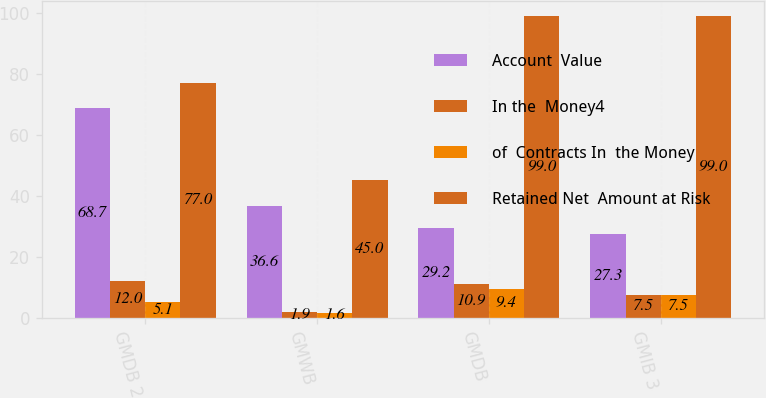<chart> <loc_0><loc_0><loc_500><loc_500><stacked_bar_chart><ecel><fcel>GMDB 2<fcel>GMWB<fcel>GMDB<fcel>GMIB 3<nl><fcel>Account  Value<fcel>68.7<fcel>36.6<fcel>29.2<fcel>27.3<nl><fcel>In the  Money4<fcel>12<fcel>1.9<fcel>10.9<fcel>7.5<nl><fcel>of  Contracts In  the Money<fcel>5.1<fcel>1.6<fcel>9.4<fcel>7.5<nl><fcel>Retained Net  Amount at Risk<fcel>77<fcel>45<fcel>99<fcel>99<nl></chart> 